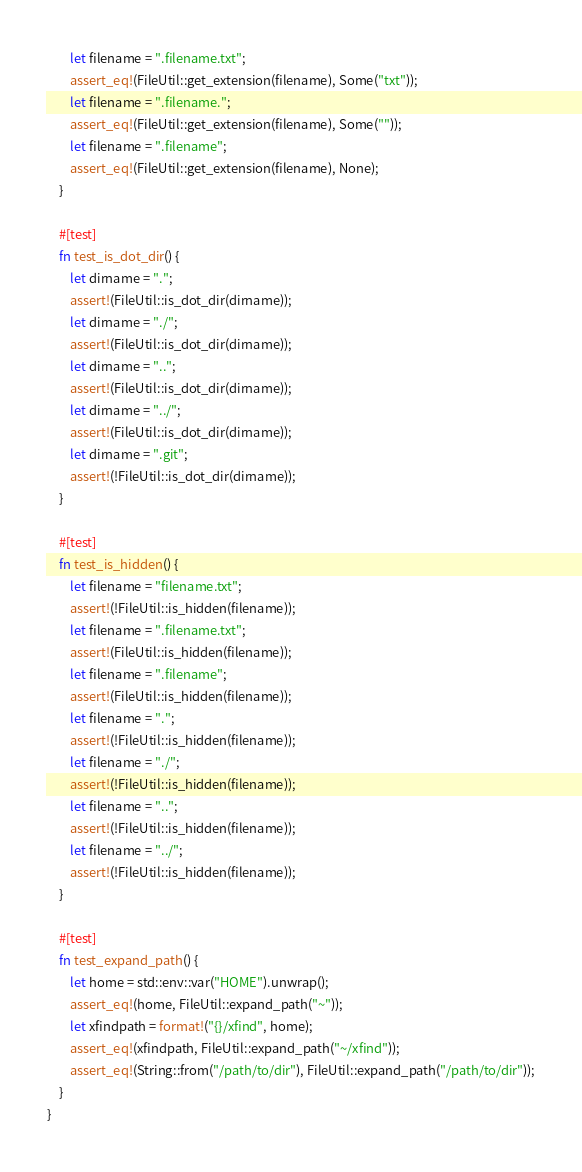Convert code to text. <code><loc_0><loc_0><loc_500><loc_500><_Rust_>        let filename = ".filename.txt";
        assert_eq!(FileUtil::get_extension(filename), Some("txt"));
        let filename = ".filename.";
        assert_eq!(FileUtil::get_extension(filename), Some(""));
        let filename = ".filename";
        assert_eq!(FileUtil::get_extension(filename), None);
    }

    #[test]
    fn test_is_dot_dir() {
        let dirname = ".";
        assert!(FileUtil::is_dot_dir(dirname));
        let dirname = "./";
        assert!(FileUtil::is_dot_dir(dirname));
        let dirname = "..";
        assert!(FileUtil::is_dot_dir(dirname));
        let dirname = "../";
        assert!(FileUtil::is_dot_dir(dirname));
        let dirname = ".git";
        assert!(!FileUtil::is_dot_dir(dirname));
    }

    #[test]
    fn test_is_hidden() {
        let filename = "filename.txt";
        assert!(!FileUtil::is_hidden(filename));
        let filename = ".filename.txt";
        assert!(FileUtil::is_hidden(filename));
        let filename = ".filename";
        assert!(FileUtil::is_hidden(filename));
        let filename = ".";
        assert!(!FileUtil::is_hidden(filename));
        let filename = "./";
        assert!(!FileUtil::is_hidden(filename));
        let filename = "..";
        assert!(!FileUtil::is_hidden(filename));
        let filename = "../";
        assert!(!FileUtil::is_hidden(filename));
    }

    #[test]
    fn test_expand_path() {
        let home = std::env::var("HOME").unwrap();
        assert_eq!(home, FileUtil::expand_path("~"));
        let xfindpath = format!("{}/xfind", home);
        assert_eq!(xfindpath, FileUtil::expand_path("~/xfind"));
        assert_eq!(String::from("/path/to/dir"), FileUtil::expand_path("/path/to/dir"));
    }
}
</code> 